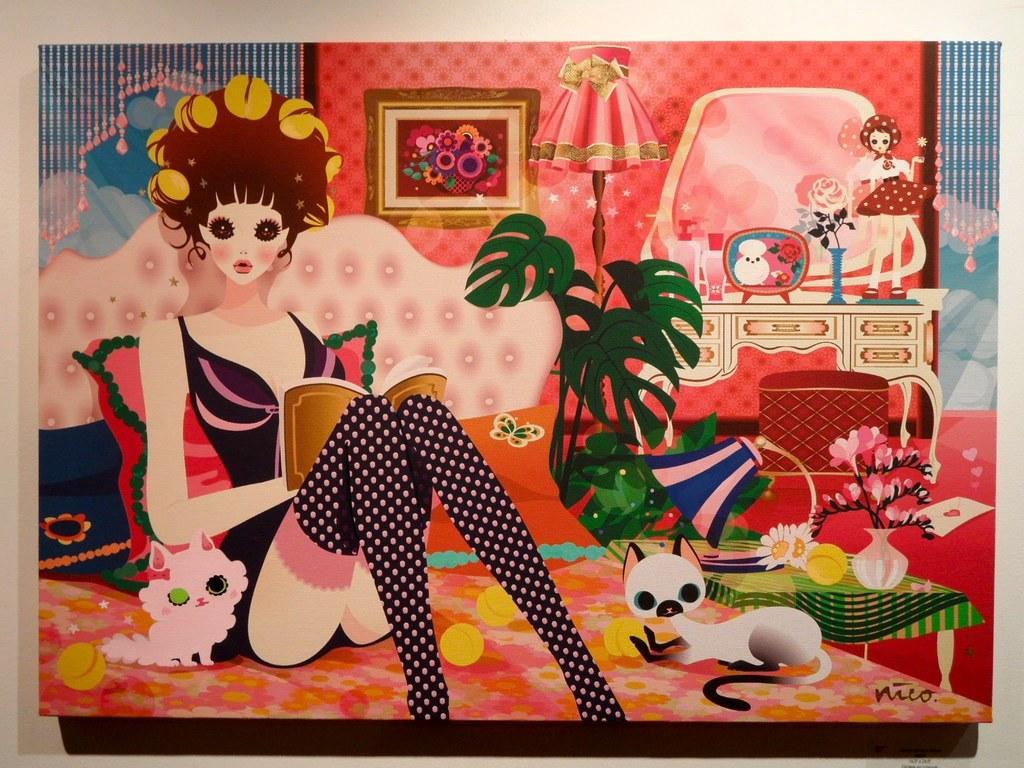Describe this image in one or two sentences. In this picture, we see the photo frame of the cartoon having a girl, lamp, toys, bed, cat and a flower vase are placed on the wall which is white in color. 